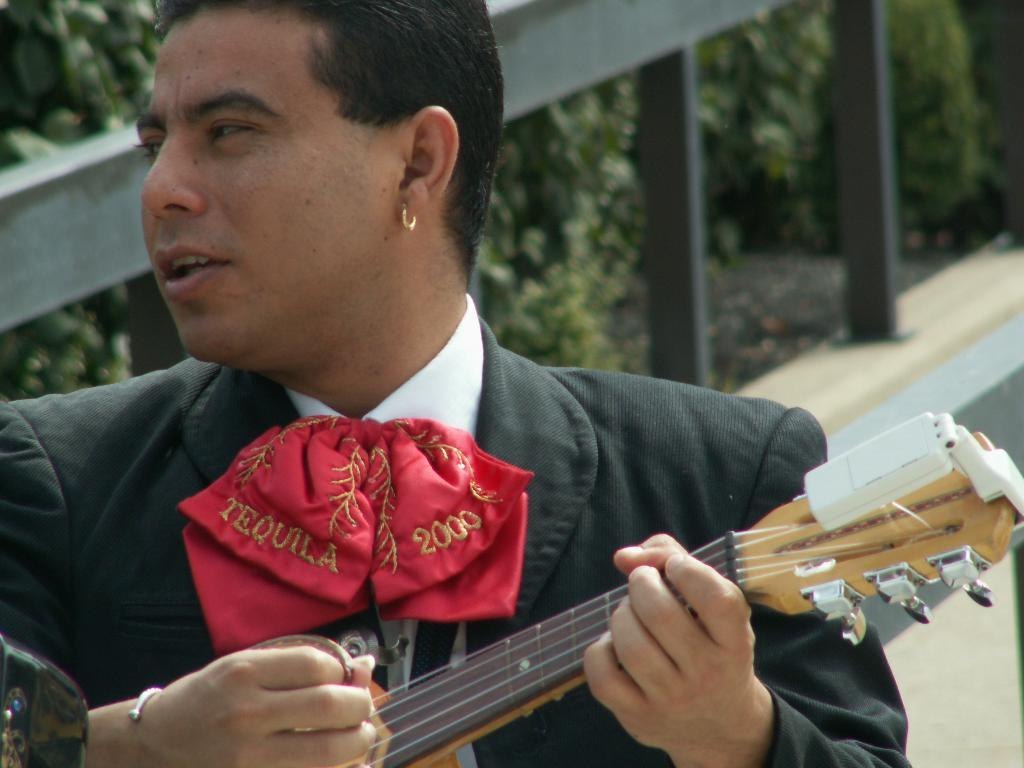What is the main subject of the image? There is a person in the image. What is the person wearing? The person is wearing a black suit and a red tie. What is the person doing in the image? The person is playing a guitar. Can you see any yaks in the image? No, there are no yaks present in the image. What type of fish is being used as a pick for the guitar? There is no fish present in the image, and the guitar does not have a pick made of fish. 